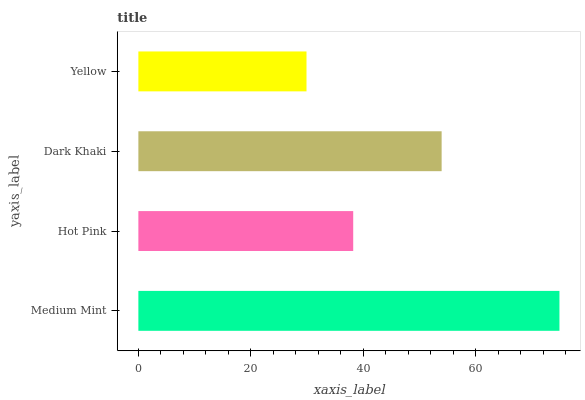Is Yellow the minimum?
Answer yes or no. Yes. Is Medium Mint the maximum?
Answer yes or no. Yes. Is Hot Pink the minimum?
Answer yes or no. No. Is Hot Pink the maximum?
Answer yes or no. No. Is Medium Mint greater than Hot Pink?
Answer yes or no. Yes. Is Hot Pink less than Medium Mint?
Answer yes or no. Yes. Is Hot Pink greater than Medium Mint?
Answer yes or no. No. Is Medium Mint less than Hot Pink?
Answer yes or no. No. Is Dark Khaki the high median?
Answer yes or no. Yes. Is Hot Pink the low median?
Answer yes or no. Yes. Is Hot Pink the high median?
Answer yes or no. No. Is Dark Khaki the low median?
Answer yes or no. No. 